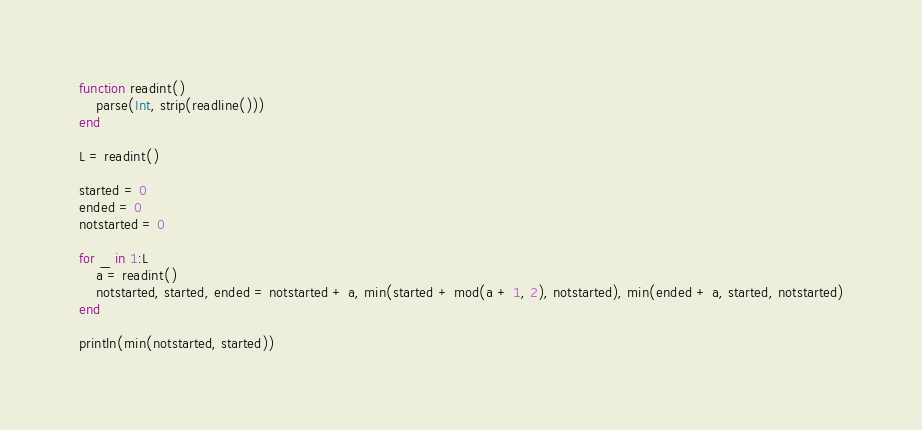<code> <loc_0><loc_0><loc_500><loc_500><_Julia_>function readint()
    parse(Int, strip(readline()))
end

L = readint()

started = 0
ended = 0
notstarted = 0

for _ in 1:L
    a = readint()
    notstarted, started, ended = notstarted + a, min(started + mod(a + 1, 2), notstarted), min(ended + a, started, notstarted)
end

println(min(notstarted, started))</code> 